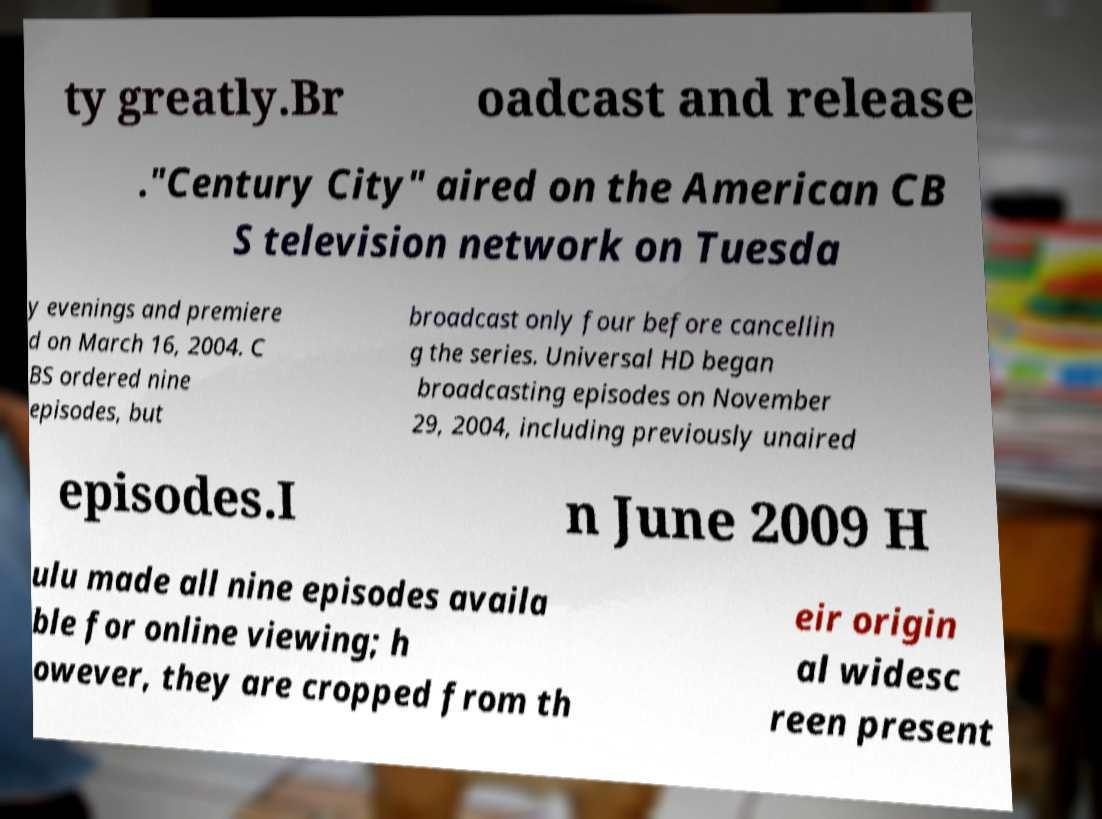Could you assist in decoding the text presented in this image and type it out clearly? ty greatly.Br oadcast and release ."Century City" aired on the American CB S television network on Tuesda y evenings and premiere d on March 16, 2004. C BS ordered nine episodes, but broadcast only four before cancellin g the series. Universal HD began broadcasting episodes on November 29, 2004, including previously unaired episodes.I n June 2009 H ulu made all nine episodes availa ble for online viewing; h owever, they are cropped from th eir origin al widesc reen present 